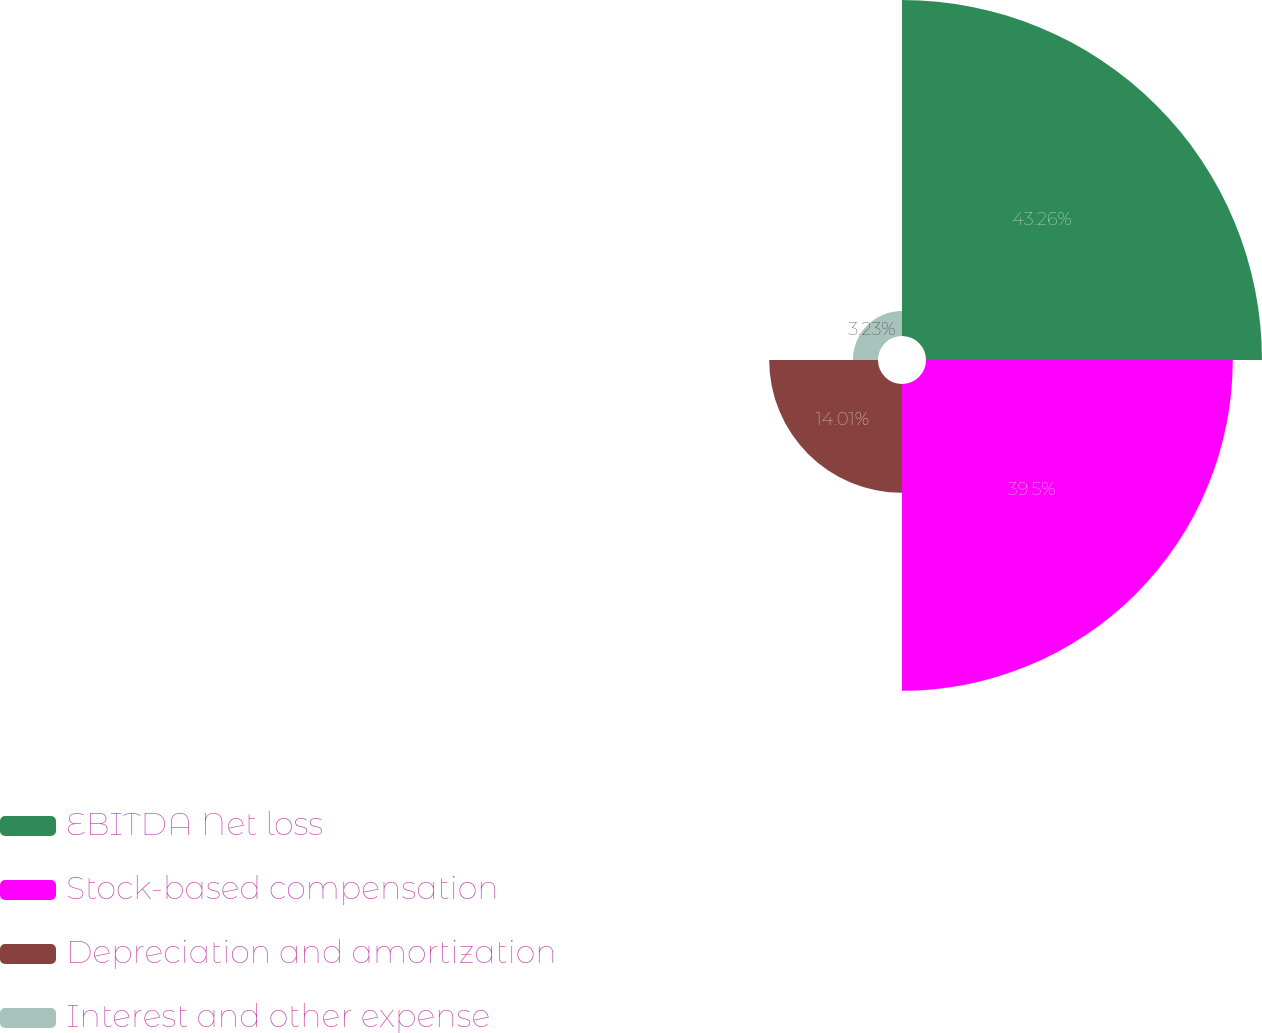Convert chart. <chart><loc_0><loc_0><loc_500><loc_500><pie_chart><fcel>EBITDA Net loss<fcel>Stock-based compensation<fcel>Depreciation and amortization<fcel>Interest and other expense<nl><fcel>43.26%<fcel>39.5%<fcel>14.01%<fcel>3.23%<nl></chart> 